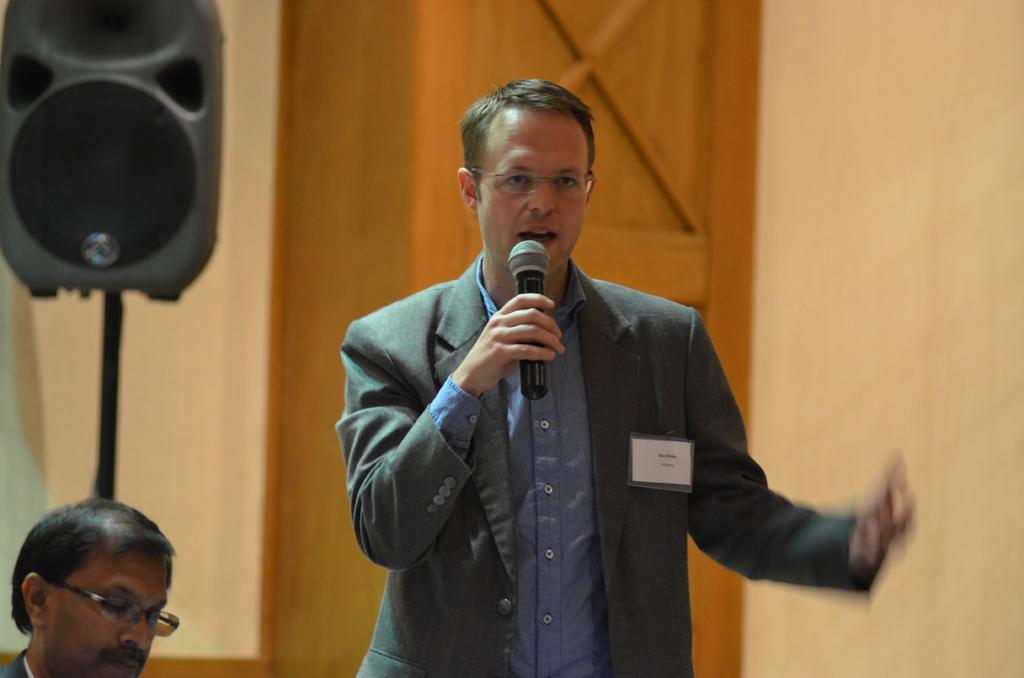Who is present in the image? There is a man in the image. What is the man wearing? The man is wearing a suit. What is the man holding in his right hand? The man is holding a mic in his right hand. What can be seen near the man? There is a speaker visible in the image. Is there anyone else in the image besides the man? Yes, there is a person beside the man. What type of soap is the man using to clean his hands in the image? There is no soap present in the image, and the man is not shown cleaning his hands. 